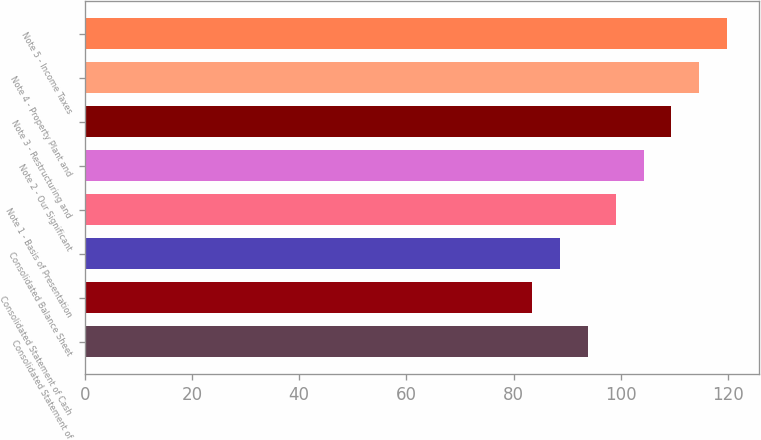<chart> <loc_0><loc_0><loc_500><loc_500><bar_chart><fcel>Consolidated Statement of<fcel>Consolidated Statement of Cash<fcel>Consolidated Balance Sheet<fcel>Note 1 - Basis of Presentation<fcel>Note 2 - Our Significant<fcel>Note 3 - Restructuring and<fcel>Note 4 - Property Plant and<fcel>Note 5 - Income Taxes<nl><fcel>93.8<fcel>83.4<fcel>88.6<fcel>99<fcel>104.2<fcel>109.4<fcel>114.6<fcel>119.8<nl></chart> 